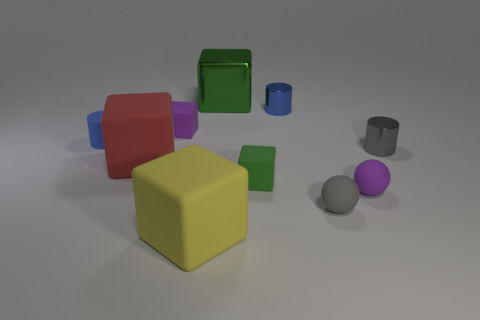Do the cube in front of the gray rubber object and the gray object that is behind the red rubber object have the same material?
Make the answer very short. No. How many objects are either gray spheres or small matte objects left of the large green object?
Ensure brevity in your answer.  3. Is there another green object of the same shape as the large green metal object?
Offer a terse response. Yes. There is a gray object right of the purple matte thing in front of the small green object that is in front of the blue rubber cylinder; what size is it?
Your response must be concise. Small. Are there an equal number of small blue cylinders that are to the right of the small green thing and blue metal cylinders behind the small blue matte cylinder?
Offer a very short reply. Yes. There is a yellow cube that is the same material as the big red thing; what size is it?
Offer a terse response. Large. The metallic cube is what color?
Offer a terse response. Green. What number of other metallic blocks are the same color as the big metal block?
Keep it short and to the point. 0. There is a purple ball that is the same size as the blue matte object; what is it made of?
Give a very brief answer. Rubber. There is a tiny blue object in front of the purple matte cube; are there any tiny blue shiny objects that are to the left of it?
Give a very brief answer. No. 